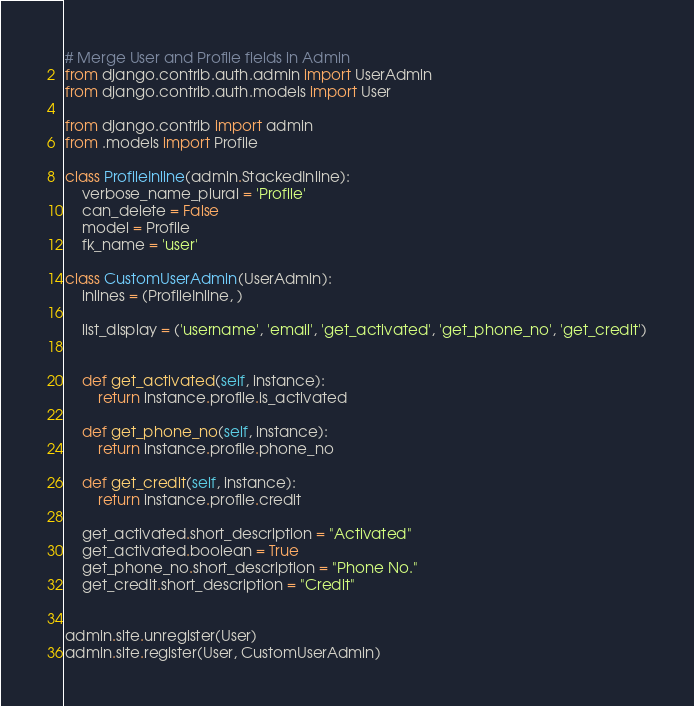<code> <loc_0><loc_0><loc_500><loc_500><_Python_># Merge User and Profile fields in Admin
from django.contrib.auth.admin import UserAdmin
from django.contrib.auth.models import User

from django.contrib import admin
from .models import Profile

class ProfileInline(admin.StackedInline):
    verbose_name_plural = 'Profile'
    can_delete = False
    model = Profile
    fk_name = 'user'

class CustomUserAdmin(UserAdmin):
    inlines = (ProfileInline, )

    list_display = ('username', 'email', 'get_activated', 'get_phone_no', 'get_credit')


    def get_activated(self, instance):
        return instance.profile.is_activated
    
    def get_phone_no(self, instance):
        return instance.profile.phone_no
    
    def get_credit(self, instance):
        return instance.profile.credit

    get_activated.short_description = "Activated"
    get_activated.boolean = True
    get_phone_no.short_description = "Phone No."
    get_credit.short_description = "Credit"


admin.site.unregister(User)
admin.site.register(User, CustomUserAdmin)


</code> 